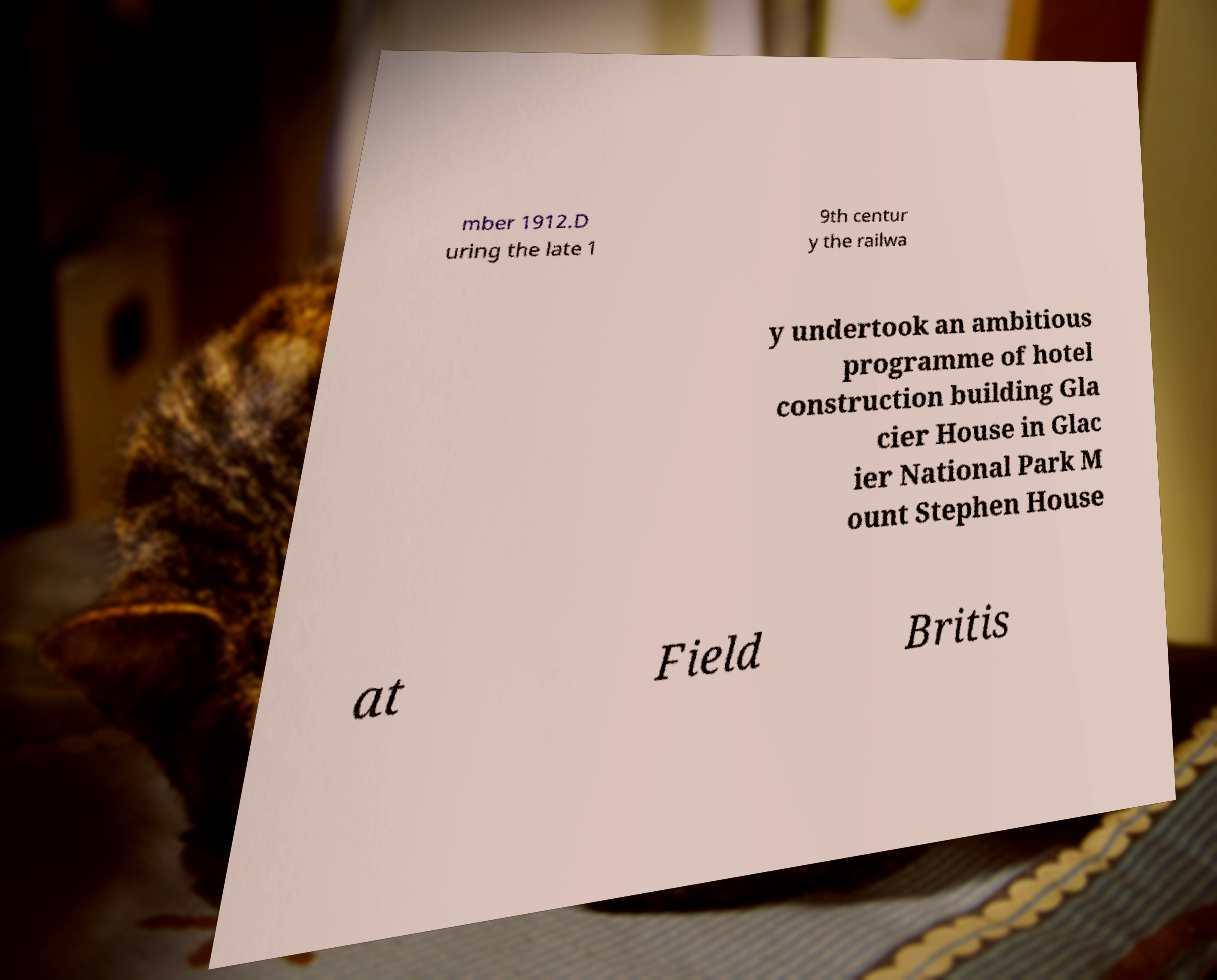Can you read and provide the text displayed in the image?This photo seems to have some interesting text. Can you extract and type it out for me? mber 1912.D uring the late 1 9th centur y the railwa y undertook an ambitious programme of hotel construction building Gla cier House in Glac ier National Park M ount Stephen House at Field Britis 